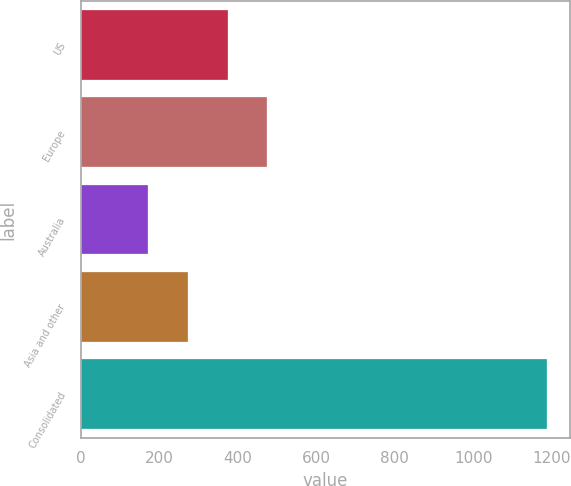Convert chart. <chart><loc_0><loc_0><loc_500><loc_500><bar_chart><fcel>US<fcel>Europe<fcel>Australia<fcel>Asia and other<fcel>Consolidated<nl><fcel>374.04<fcel>475.81<fcel>170.5<fcel>272.27<fcel>1188.2<nl></chart> 